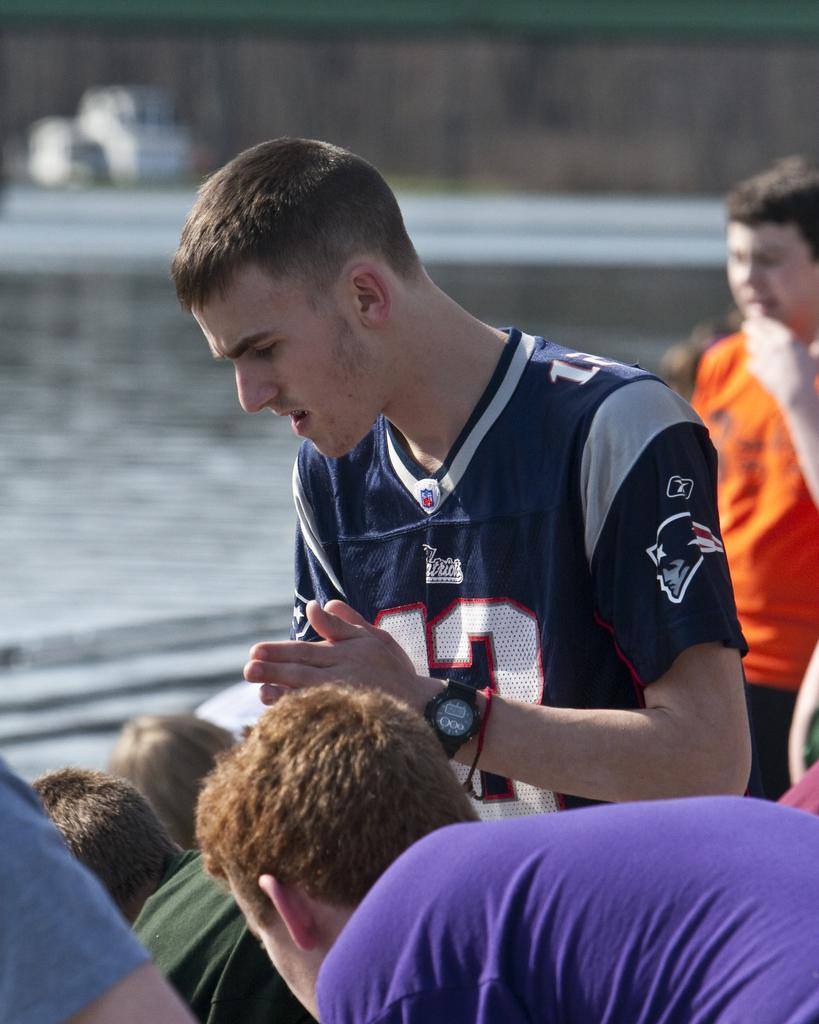<image>
Offer a succinct explanation of the picture presented. Number 13 is shown on the New England Patriot jersey this man is wearing. 